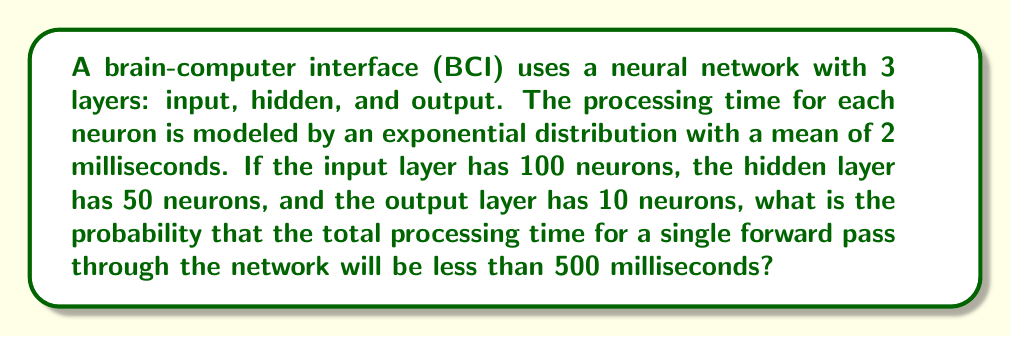Provide a solution to this math problem. Let's approach this step-by-step:

1) First, we need to calculate the total number of neurons in the network:
   $100 + 50 + 10 = 160$ neurons

2) The processing time for each neuron follows an exponential distribution with mean $\lambda = 2$ ms. The sum of independent exponential distributions follows a gamma distribution.

3) The shape parameter $k$ of the resulting gamma distribution is equal to the number of neurons (160), and the scale parameter $\theta$ is equal to the mean of each exponential distribution (2 ms).

4) We want to find $P(X < 500)$ where $X$ follows a gamma distribution with $k = 160$ and $\theta = 2$.

5) The cumulative distribution function (CDF) of a gamma distribution is given by the regularized gamma function:

   $P(X < x) = \frac{\gamma(k, x/\theta)}{\Gamma(k)}$

   where $\gamma(k, x/\theta)$ is the lower incomplete gamma function and $\Gamma(k)$ is the gamma function.

6) Plugging in our values:

   $P(X < 500) = \frac{\gamma(160, 500/2)}{\Gamma(160)}$

7) This can be calculated using statistical software or programming languages with gamma function implementations. Using such tools, we get:

   $P(X < 500) \approx 0.9999999999999999$

8) This extremely high probability makes sense intuitively. The expected total processing time is $160 * 2 = 320$ ms, and 500 ms is significantly higher than this, allowing for a large margin.
Answer: $\approx 0.9999999999999999$ 